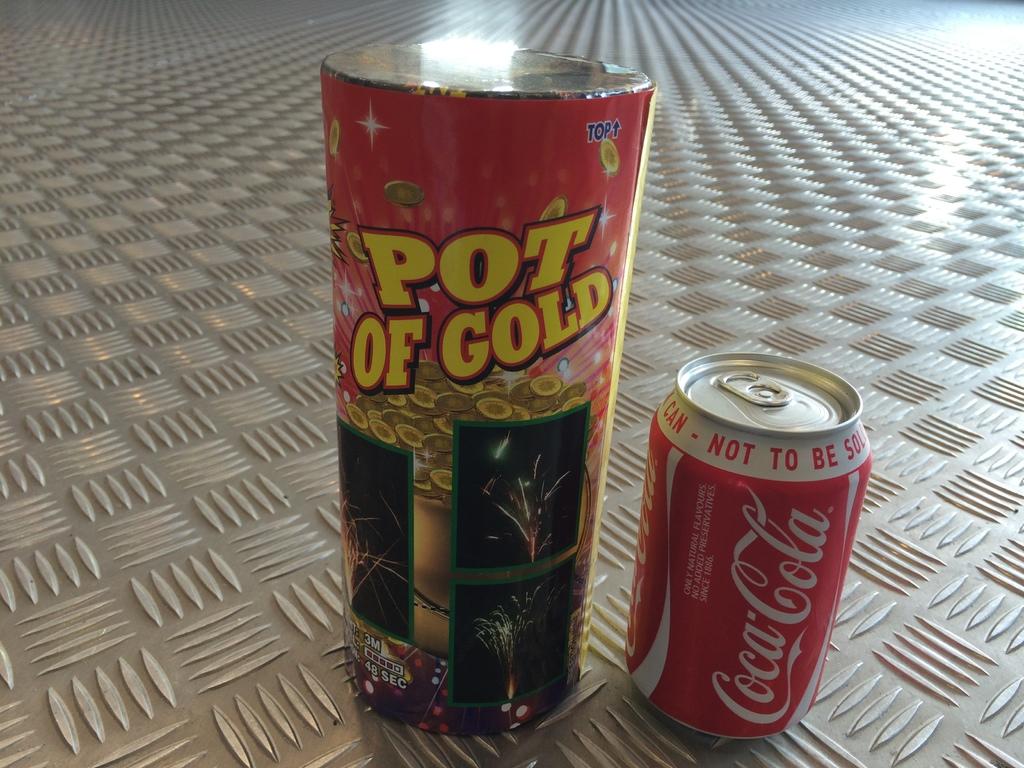What kind of soda is that?
Your response must be concise. Coca cola. 